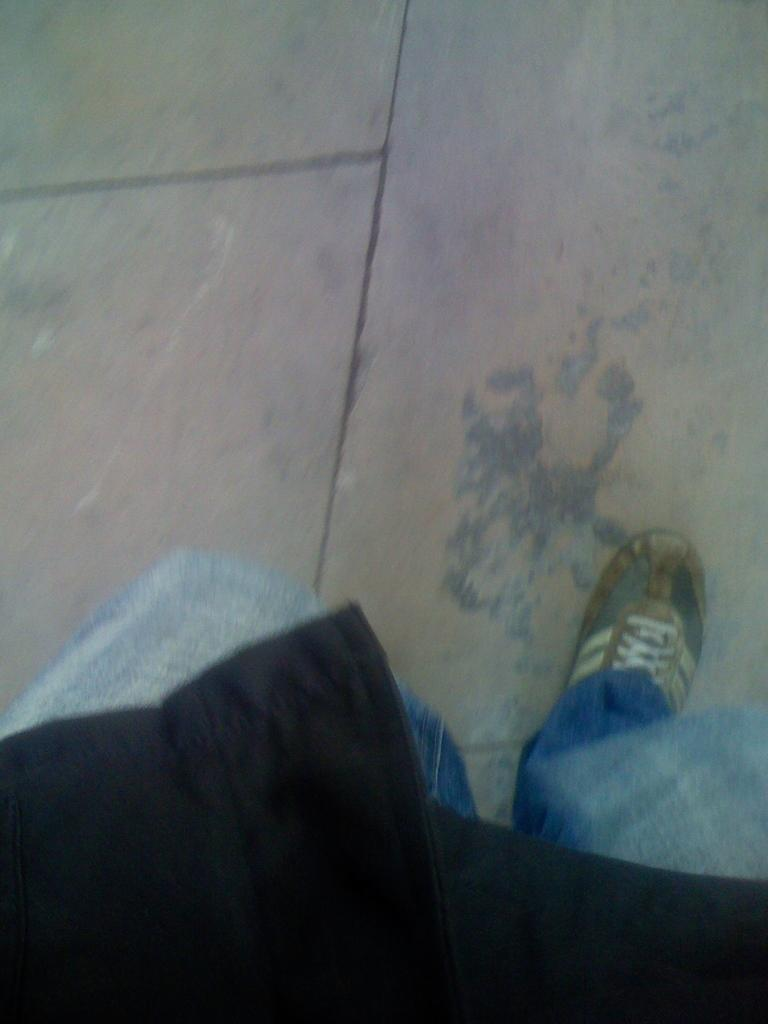What type of living being is present in the image? There is a human in the picture. What surface is visible in the image? There is a floor visible in the picture. What type of voyage is the human embarking on in the image? There is no indication of a voyage in the image; it only shows a human and a floor. 